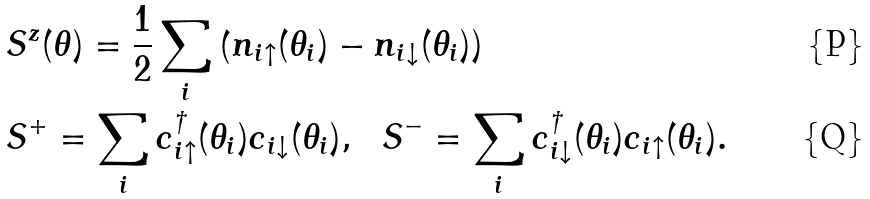Convert formula to latex. <formula><loc_0><loc_0><loc_500><loc_500>& S ^ { z } ( \theta ) = \frac { 1 } { 2 } \sum _ { i } \left ( n _ { i \uparrow } ( \theta _ { i } ) - n _ { i \downarrow } ( \theta _ { i } ) \right ) \\ & S ^ { + } = \sum _ { i } c _ { i \uparrow } ^ { \dag } ( \theta _ { i } ) c _ { i \downarrow } ( \theta _ { i } ) , \ \ S ^ { - } = \sum _ { i } c _ { i \downarrow } ^ { \dag } ( \theta _ { i } ) c _ { i \uparrow } ( \theta _ { i } ) .</formula> 